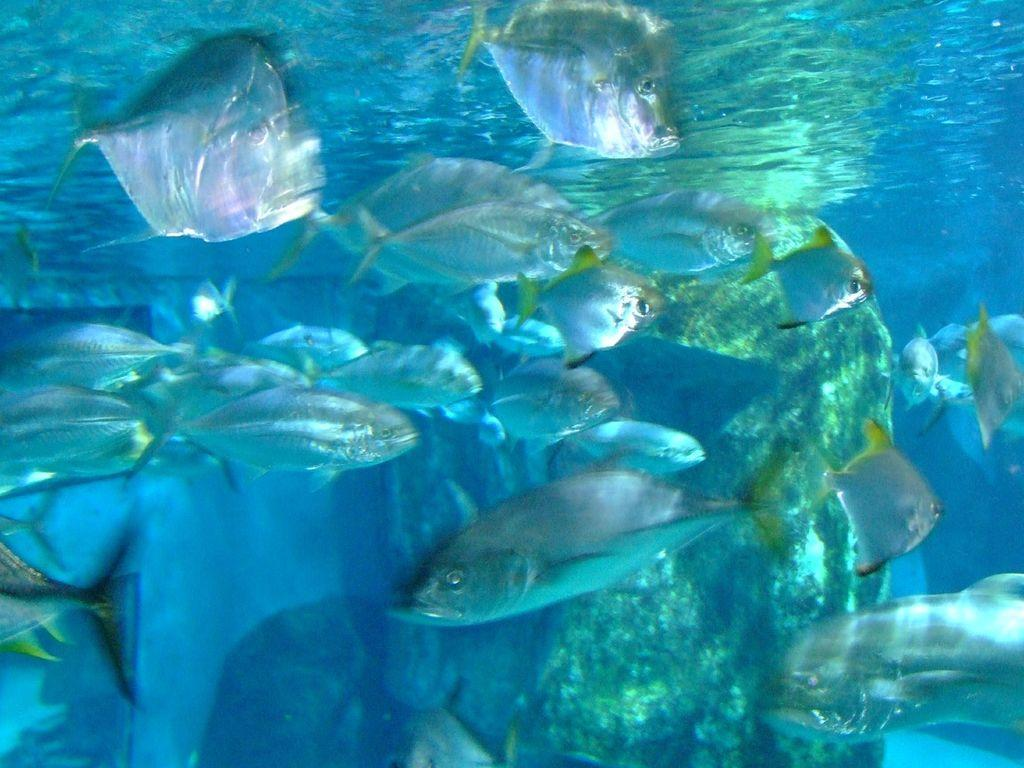What type of animals are in the image? There are fishes in the image. Where are the fishes located? The fishes are in the water. What type of list can be seen in the image? There is no list present in the image; it features fishes in the water. What stage of development are the marbles in the image? There are no marbles present in the image; it features fishes in the water. 